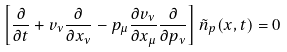Convert formula to latex. <formula><loc_0><loc_0><loc_500><loc_500>\left [ \frac { \partial } { \partial t } + v _ { \nu } \frac { \partial } { \partial x _ { \nu } } - p _ { \mu } \frac { \partial v _ { \nu } } { \partial x _ { \mu } } \frac { \partial } { \partial p _ { \nu } } \right ] \tilde { n } _ { p } ( { x } , t ) = 0</formula> 